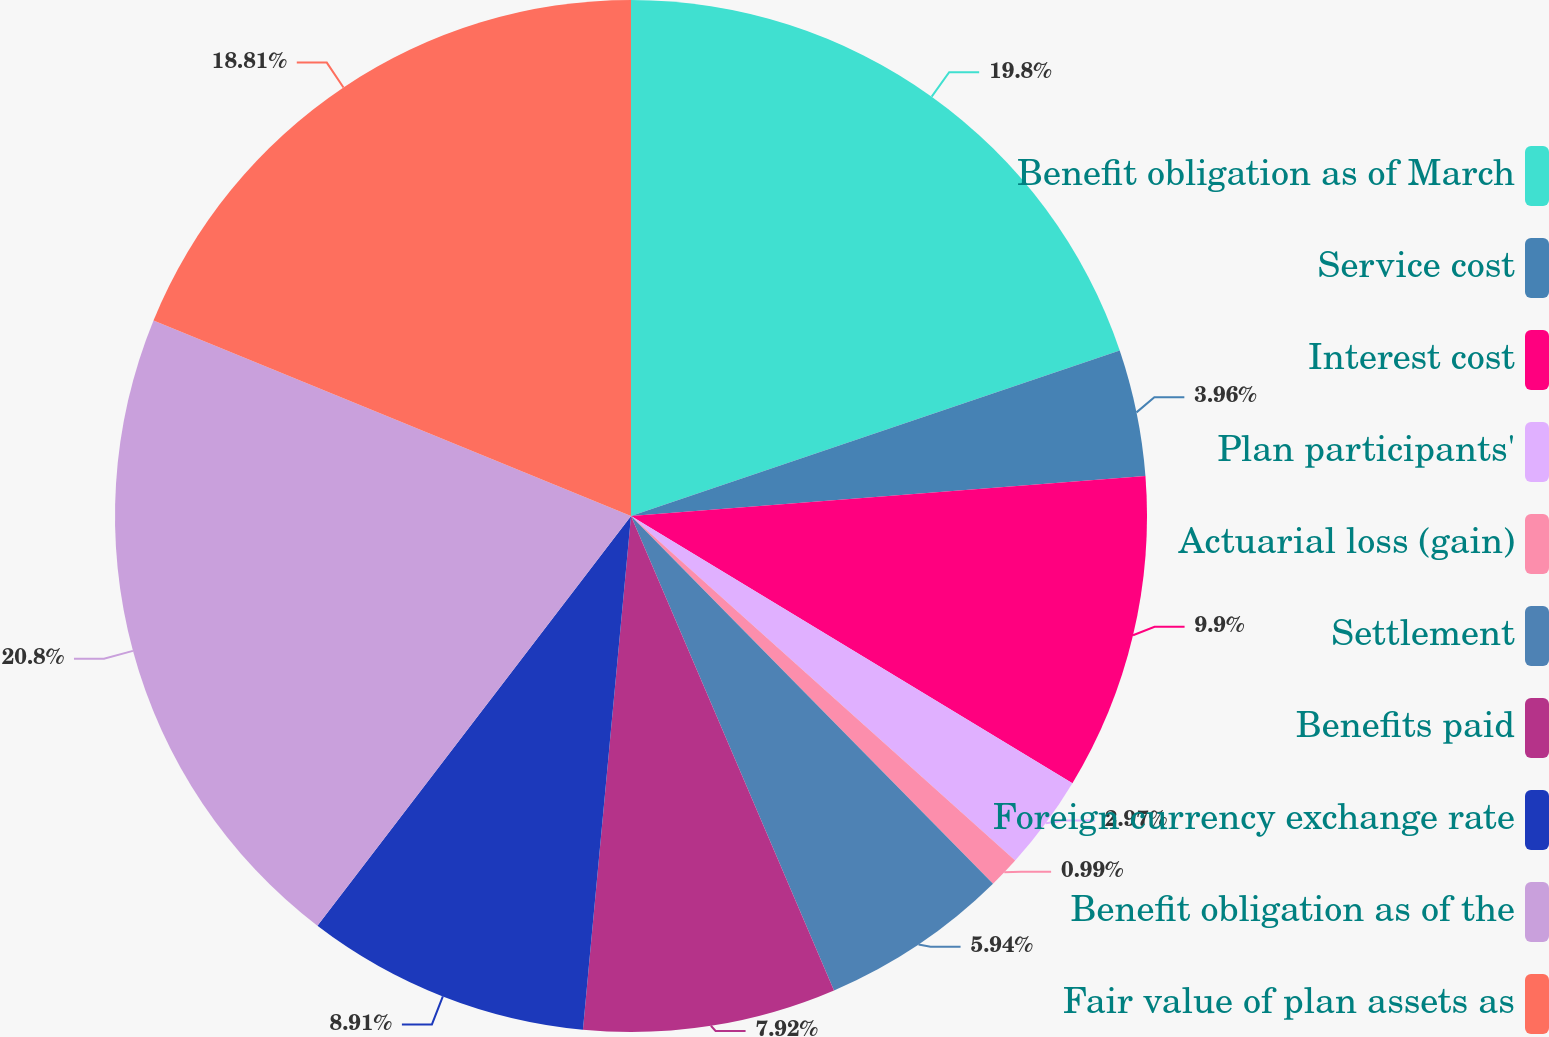Convert chart. <chart><loc_0><loc_0><loc_500><loc_500><pie_chart><fcel>Benefit obligation as of March<fcel>Service cost<fcel>Interest cost<fcel>Plan participants'<fcel>Actuarial loss (gain)<fcel>Settlement<fcel>Benefits paid<fcel>Foreign currency exchange rate<fcel>Benefit obligation as of the<fcel>Fair value of plan assets as<nl><fcel>19.8%<fcel>3.96%<fcel>9.9%<fcel>2.97%<fcel>0.99%<fcel>5.94%<fcel>7.92%<fcel>8.91%<fcel>20.79%<fcel>18.81%<nl></chart> 